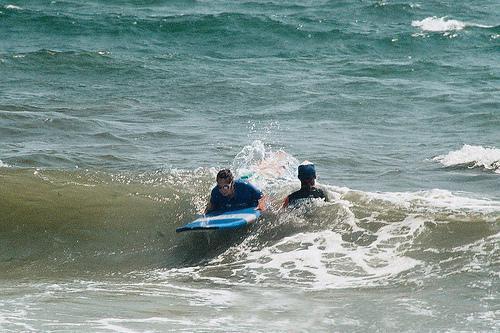How many people are there?
Give a very brief answer. 2. 